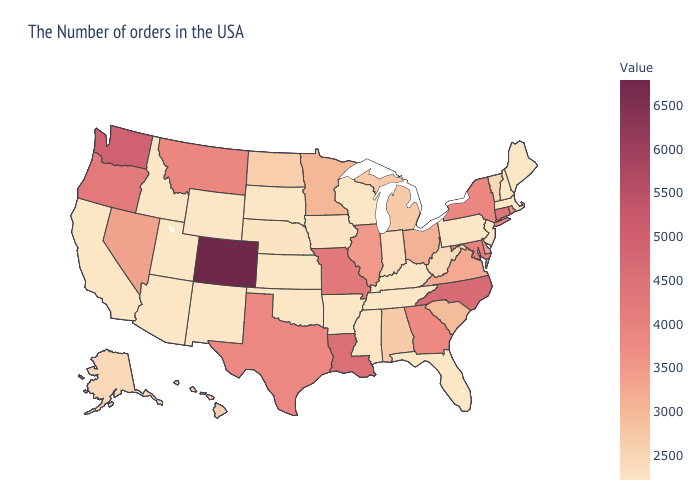Does Colorado have the highest value in the USA?
Quick response, please. Yes. Among the states that border South Dakota , which have the lowest value?
Quick response, please. Wyoming. Among the states that border New Hampshire , which have the highest value?
Answer briefly. Vermont. Does the map have missing data?
Short answer required. No. Which states have the highest value in the USA?
Give a very brief answer. Colorado. Does California have a higher value than Georgia?
Short answer required. No. 